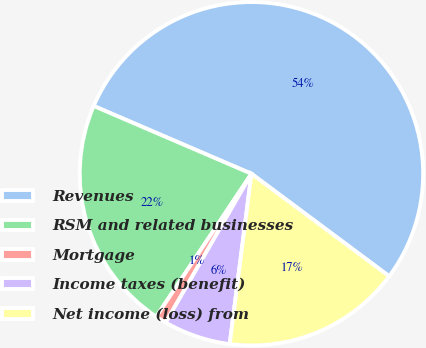Convert chart. <chart><loc_0><loc_0><loc_500><loc_500><pie_chart><fcel>Revenues<fcel>RSM and related businesses<fcel>Mortgage<fcel>Income taxes (benefit)<fcel>Net income (loss) from<nl><fcel>53.73%<fcel>22.11%<fcel>1.03%<fcel>6.3%<fcel>16.84%<nl></chart> 